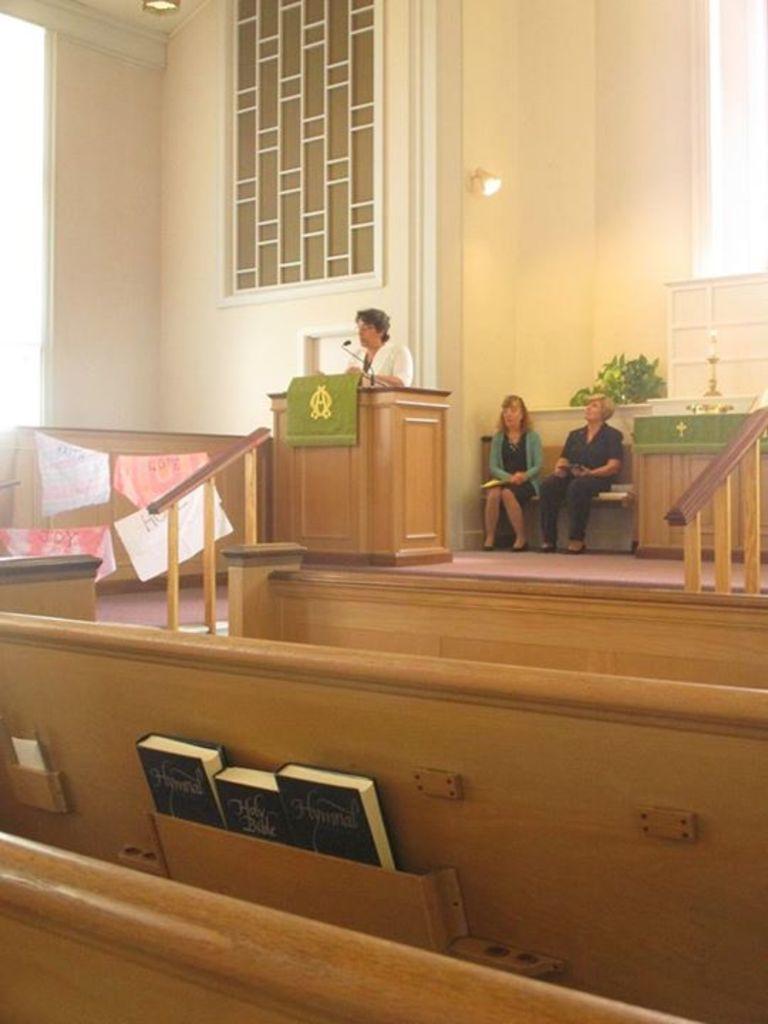Can you describe this image briefly? This picture shows two men seated and a woman standing at the podium and speaking with the help of a microphone and we see three books in the stand 